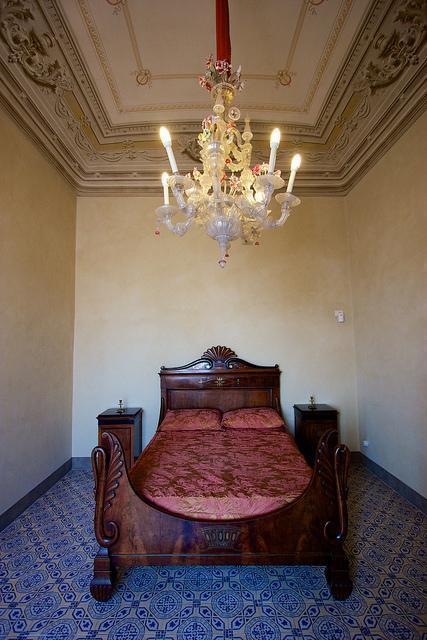How many beds are in the photo?
Give a very brief answer. 1. 